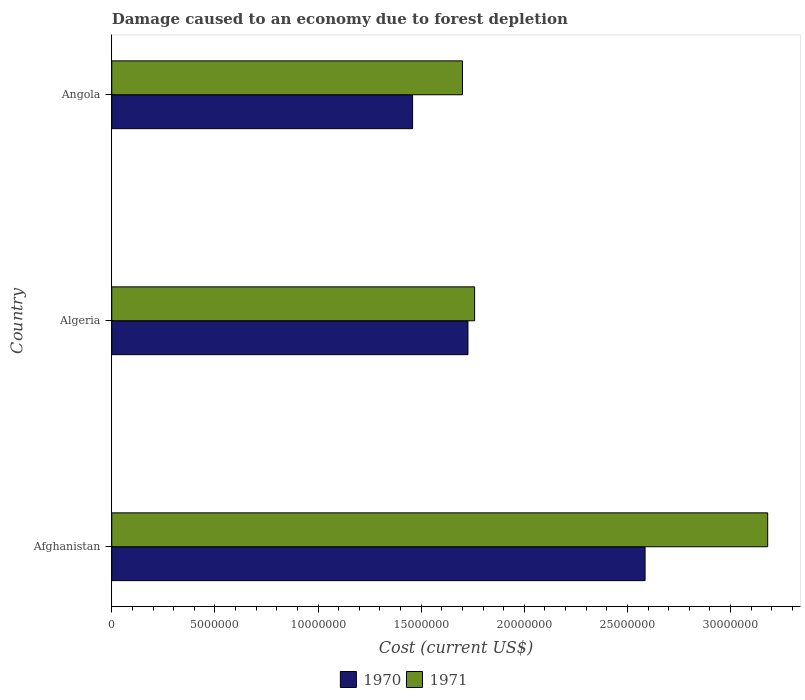Are the number of bars per tick equal to the number of legend labels?
Provide a succinct answer. Yes. Are the number of bars on each tick of the Y-axis equal?
Make the answer very short. Yes. How many bars are there on the 1st tick from the bottom?
Your answer should be compact. 2. What is the label of the 2nd group of bars from the top?
Offer a terse response. Algeria. In how many cases, is the number of bars for a given country not equal to the number of legend labels?
Give a very brief answer. 0. What is the cost of damage caused due to forest depletion in 1971 in Algeria?
Your answer should be very brief. 1.76e+07. Across all countries, what is the maximum cost of damage caused due to forest depletion in 1971?
Your response must be concise. 3.18e+07. Across all countries, what is the minimum cost of damage caused due to forest depletion in 1970?
Provide a short and direct response. 1.46e+07. In which country was the cost of damage caused due to forest depletion in 1970 maximum?
Keep it short and to the point. Afghanistan. In which country was the cost of damage caused due to forest depletion in 1971 minimum?
Your response must be concise. Angola. What is the total cost of damage caused due to forest depletion in 1971 in the graph?
Provide a succinct answer. 6.64e+07. What is the difference between the cost of damage caused due to forest depletion in 1970 in Algeria and that in Angola?
Offer a terse response. 2.69e+06. What is the difference between the cost of damage caused due to forest depletion in 1971 in Angola and the cost of damage caused due to forest depletion in 1970 in Afghanistan?
Your response must be concise. -8.85e+06. What is the average cost of damage caused due to forest depletion in 1970 per country?
Ensure brevity in your answer.  1.92e+07. What is the difference between the cost of damage caused due to forest depletion in 1970 and cost of damage caused due to forest depletion in 1971 in Algeria?
Keep it short and to the point. -3.23e+05. What is the ratio of the cost of damage caused due to forest depletion in 1970 in Afghanistan to that in Angola?
Offer a terse response. 1.77. Is the difference between the cost of damage caused due to forest depletion in 1970 in Afghanistan and Algeria greater than the difference between the cost of damage caused due to forest depletion in 1971 in Afghanistan and Algeria?
Your answer should be very brief. No. What is the difference between the highest and the second highest cost of damage caused due to forest depletion in 1971?
Keep it short and to the point. 1.42e+07. What is the difference between the highest and the lowest cost of damage caused due to forest depletion in 1971?
Your answer should be very brief. 1.48e+07. In how many countries, is the cost of damage caused due to forest depletion in 1971 greater than the average cost of damage caused due to forest depletion in 1971 taken over all countries?
Keep it short and to the point. 1. Is the sum of the cost of damage caused due to forest depletion in 1971 in Algeria and Angola greater than the maximum cost of damage caused due to forest depletion in 1970 across all countries?
Provide a succinct answer. Yes. What does the 1st bar from the top in Algeria represents?
Make the answer very short. 1971. What does the 2nd bar from the bottom in Angola represents?
Offer a very short reply. 1971. How many bars are there?
Provide a succinct answer. 6. How many countries are there in the graph?
Your answer should be very brief. 3. Does the graph contain any zero values?
Your answer should be very brief. No. Does the graph contain grids?
Your response must be concise. No. What is the title of the graph?
Your answer should be compact. Damage caused to an economy due to forest depletion. Does "1981" appear as one of the legend labels in the graph?
Provide a short and direct response. No. What is the label or title of the X-axis?
Offer a terse response. Cost (current US$). What is the Cost (current US$) in 1970 in Afghanistan?
Keep it short and to the point. 2.59e+07. What is the Cost (current US$) in 1971 in Afghanistan?
Provide a succinct answer. 3.18e+07. What is the Cost (current US$) of 1970 in Algeria?
Make the answer very short. 1.73e+07. What is the Cost (current US$) of 1971 in Algeria?
Make the answer very short. 1.76e+07. What is the Cost (current US$) of 1970 in Angola?
Provide a succinct answer. 1.46e+07. What is the Cost (current US$) in 1971 in Angola?
Give a very brief answer. 1.70e+07. Across all countries, what is the maximum Cost (current US$) of 1970?
Provide a succinct answer. 2.59e+07. Across all countries, what is the maximum Cost (current US$) in 1971?
Your answer should be very brief. 3.18e+07. Across all countries, what is the minimum Cost (current US$) of 1970?
Provide a short and direct response. 1.46e+07. Across all countries, what is the minimum Cost (current US$) of 1971?
Provide a short and direct response. 1.70e+07. What is the total Cost (current US$) in 1970 in the graph?
Keep it short and to the point. 5.77e+07. What is the total Cost (current US$) in 1971 in the graph?
Your answer should be compact. 6.64e+07. What is the difference between the Cost (current US$) in 1970 in Afghanistan and that in Algeria?
Make the answer very short. 8.59e+06. What is the difference between the Cost (current US$) in 1971 in Afghanistan and that in Algeria?
Your answer should be compact. 1.42e+07. What is the difference between the Cost (current US$) of 1970 in Afghanistan and that in Angola?
Make the answer very short. 1.13e+07. What is the difference between the Cost (current US$) in 1971 in Afghanistan and that in Angola?
Ensure brevity in your answer.  1.48e+07. What is the difference between the Cost (current US$) of 1970 in Algeria and that in Angola?
Ensure brevity in your answer.  2.69e+06. What is the difference between the Cost (current US$) in 1971 in Algeria and that in Angola?
Your answer should be compact. 5.88e+05. What is the difference between the Cost (current US$) of 1970 in Afghanistan and the Cost (current US$) of 1971 in Algeria?
Make the answer very short. 8.27e+06. What is the difference between the Cost (current US$) in 1970 in Afghanistan and the Cost (current US$) in 1971 in Angola?
Offer a terse response. 8.85e+06. What is the difference between the Cost (current US$) in 1970 in Algeria and the Cost (current US$) in 1971 in Angola?
Your response must be concise. 2.66e+05. What is the average Cost (current US$) of 1970 per country?
Keep it short and to the point. 1.92e+07. What is the average Cost (current US$) in 1971 per country?
Make the answer very short. 2.21e+07. What is the difference between the Cost (current US$) of 1970 and Cost (current US$) of 1971 in Afghanistan?
Give a very brief answer. -5.95e+06. What is the difference between the Cost (current US$) of 1970 and Cost (current US$) of 1971 in Algeria?
Provide a short and direct response. -3.23e+05. What is the difference between the Cost (current US$) in 1970 and Cost (current US$) in 1971 in Angola?
Your response must be concise. -2.42e+06. What is the ratio of the Cost (current US$) in 1970 in Afghanistan to that in Algeria?
Ensure brevity in your answer.  1.5. What is the ratio of the Cost (current US$) of 1971 in Afghanistan to that in Algeria?
Provide a succinct answer. 1.81. What is the ratio of the Cost (current US$) of 1970 in Afghanistan to that in Angola?
Keep it short and to the point. 1.77. What is the ratio of the Cost (current US$) of 1971 in Afghanistan to that in Angola?
Offer a terse response. 1.87. What is the ratio of the Cost (current US$) of 1970 in Algeria to that in Angola?
Make the answer very short. 1.18. What is the ratio of the Cost (current US$) of 1971 in Algeria to that in Angola?
Ensure brevity in your answer.  1.03. What is the difference between the highest and the second highest Cost (current US$) of 1970?
Make the answer very short. 8.59e+06. What is the difference between the highest and the second highest Cost (current US$) in 1971?
Your response must be concise. 1.42e+07. What is the difference between the highest and the lowest Cost (current US$) in 1970?
Give a very brief answer. 1.13e+07. What is the difference between the highest and the lowest Cost (current US$) in 1971?
Provide a succinct answer. 1.48e+07. 